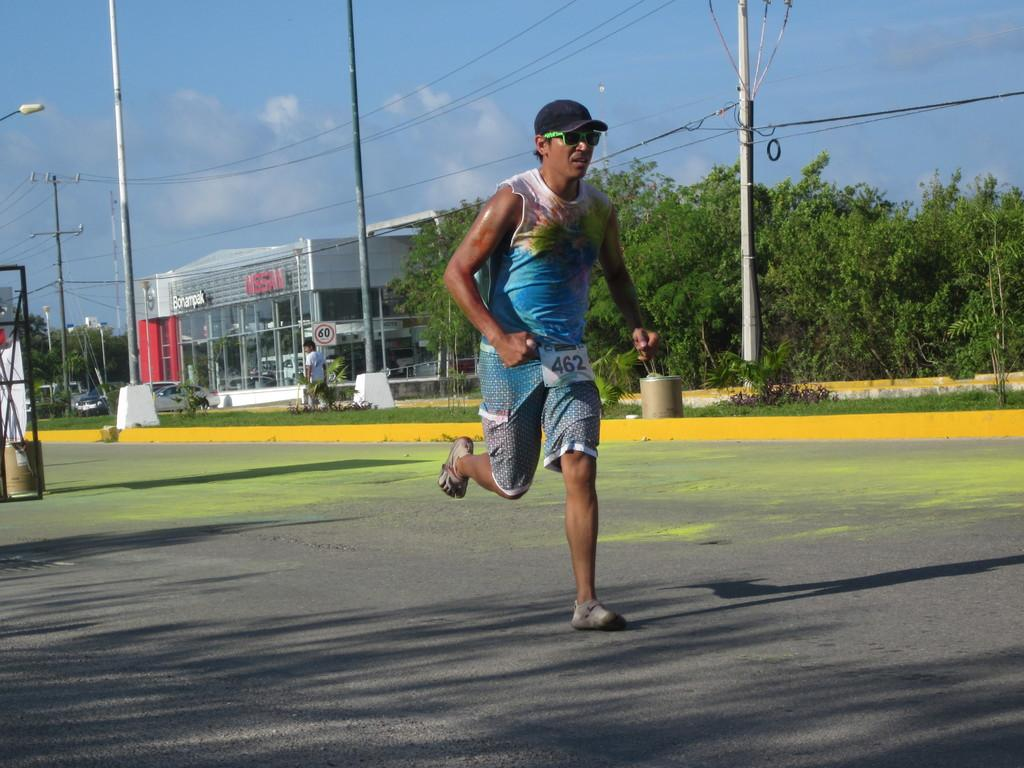What is the main subject of the image? The main subject of the image is a man. What is the man doing in the image? The man is running on the road in the image. Can you describe the man's appearance? The man is wearing spectacles and a cap in the image. What can be seen in the background of the image? In the background of the image, there are poles, cables, hoardings, buildings, trees, and vehicles. What type of furniture can be seen in the image? There is no furniture present in the image; it features a man running on the road with various background elements. 